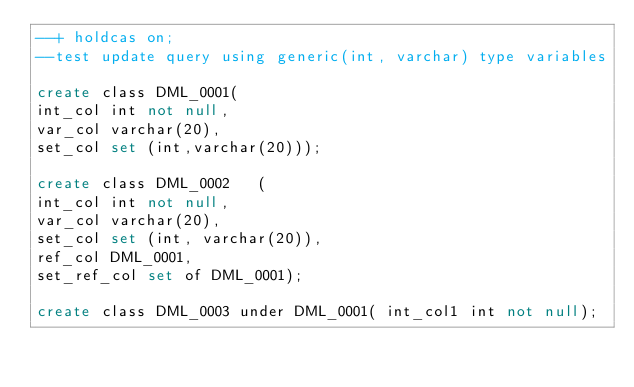Convert code to text. <code><loc_0><loc_0><loc_500><loc_500><_SQL_>--+ holdcas on;
--test update query using generic(int, varchar) type variables

create class DML_0001( 	
int_col int not null,
var_col varchar(20),
set_col set (int,varchar(20)));

create class DML_0002 	(	
int_col int not null,
var_col varchar(20),
set_col set (int, varchar(20)),
ref_col DML_0001,
set_ref_col set of DML_0001);

create class DML_0003 under DML_0001( int_col1 int not null);
</code> 